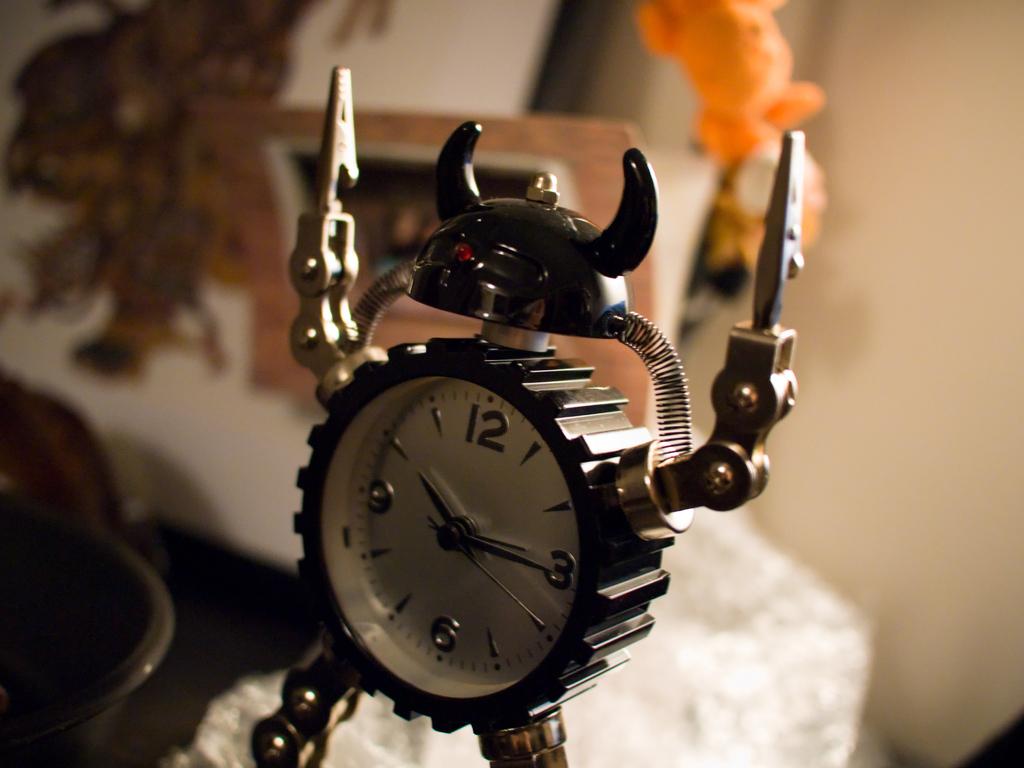What number is the minute hand on?
Your response must be concise. 3. What number is on the hour hand?
Your answer should be very brief. 10. 